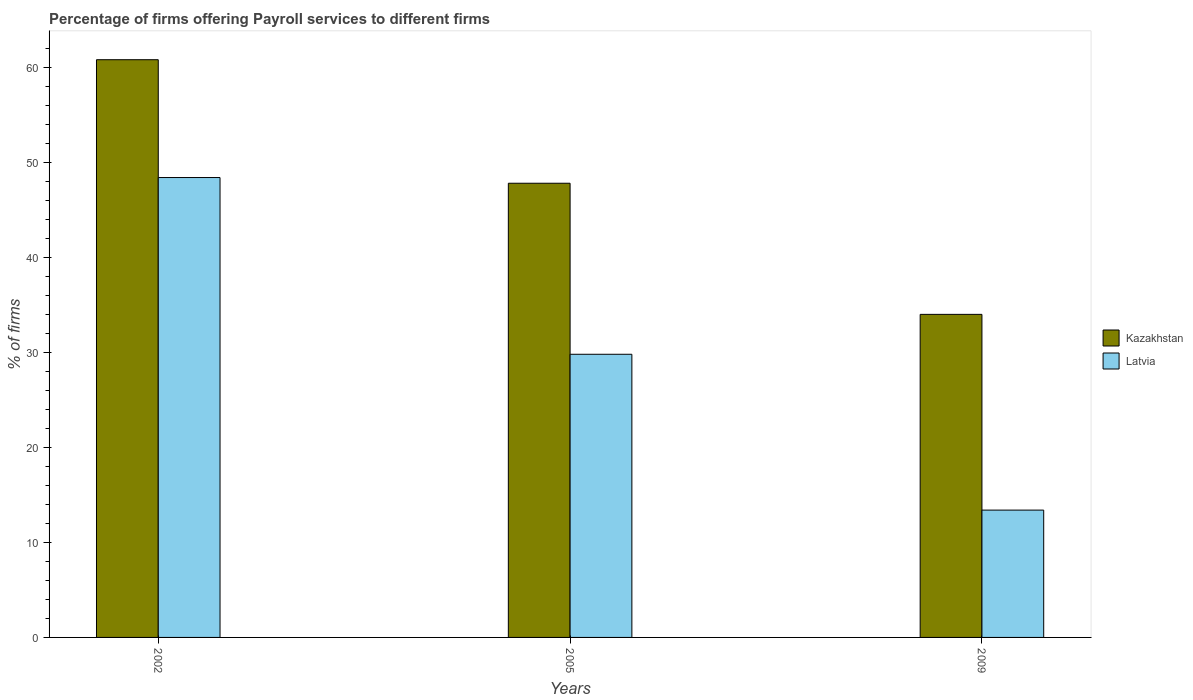Are the number of bars per tick equal to the number of legend labels?
Give a very brief answer. Yes. Are the number of bars on each tick of the X-axis equal?
Your answer should be very brief. Yes. How many bars are there on the 2nd tick from the right?
Provide a short and direct response. 2. What is the label of the 2nd group of bars from the left?
Provide a succinct answer. 2005. What is the percentage of firms offering payroll services in Kazakhstan in 2002?
Make the answer very short. 60.8. Across all years, what is the maximum percentage of firms offering payroll services in Kazakhstan?
Make the answer very short. 60.8. In which year was the percentage of firms offering payroll services in Latvia maximum?
Offer a very short reply. 2002. What is the total percentage of firms offering payroll services in Latvia in the graph?
Keep it short and to the point. 91.6. What is the difference between the percentage of firms offering payroll services in Latvia in 2002 and that in 2005?
Provide a succinct answer. 18.6. What is the difference between the percentage of firms offering payroll services in Kazakhstan in 2005 and the percentage of firms offering payroll services in Latvia in 2009?
Your response must be concise. 34.4. What is the average percentage of firms offering payroll services in Latvia per year?
Your response must be concise. 30.53. In the year 2005, what is the difference between the percentage of firms offering payroll services in Kazakhstan and percentage of firms offering payroll services in Latvia?
Offer a very short reply. 18. In how many years, is the percentage of firms offering payroll services in Kazakhstan greater than 60 %?
Offer a very short reply. 1. What is the ratio of the percentage of firms offering payroll services in Latvia in 2002 to that in 2009?
Offer a terse response. 3.61. Is the percentage of firms offering payroll services in Kazakhstan in 2002 less than that in 2005?
Your response must be concise. No. What is the difference between the highest and the second highest percentage of firms offering payroll services in Latvia?
Ensure brevity in your answer.  18.6. What is the difference between the highest and the lowest percentage of firms offering payroll services in Kazakhstan?
Offer a terse response. 26.8. What does the 1st bar from the left in 2002 represents?
Your answer should be very brief. Kazakhstan. What does the 1st bar from the right in 2005 represents?
Provide a short and direct response. Latvia. Are all the bars in the graph horizontal?
Your response must be concise. No. How many years are there in the graph?
Your answer should be compact. 3. Are the values on the major ticks of Y-axis written in scientific E-notation?
Give a very brief answer. No. Does the graph contain any zero values?
Offer a terse response. No. Does the graph contain grids?
Make the answer very short. No. Where does the legend appear in the graph?
Your answer should be compact. Center right. How are the legend labels stacked?
Keep it short and to the point. Vertical. What is the title of the graph?
Your response must be concise. Percentage of firms offering Payroll services to different firms. What is the label or title of the Y-axis?
Keep it short and to the point. % of firms. What is the % of firms of Kazakhstan in 2002?
Ensure brevity in your answer.  60.8. What is the % of firms of Latvia in 2002?
Give a very brief answer. 48.4. What is the % of firms in Kazakhstan in 2005?
Offer a terse response. 47.8. What is the % of firms in Latvia in 2005?
Offer a terse response. 29.8. What is the % of firms in Latvia in 2009?
Make the answer very short. 13.4. Across all years, what is the maximum % of firms of Kazakhstan?
Provide a succinct answer. 60.8. Across all years, what is the maximum % of firms of Latvia?
Offer a very short reply. 48.4. Across all years, what is the minimum % of firms of Kazakhstan?
Your response must be concise. 34. Across all years, what is the minimum % of firms of Latvia?
Keep it short and to the point. 13.4. What is the total % of firms in Kazakhstan in the graph?
Provide a short and direct response. 142.6. What is the total % of firms of Latvia in the graph?
Your answer should be very brief. 91.6. What is the difference between the % of firms of Kazakhstan in 2002 and that in 2005?
Offer a very short reply. 13. What is the difference between the % of firms in Latvia in 2002 and that in 2005?
Offer a very short reply. 18.6. What is the difference between the % of firms of Kazakhstan in 2002 and that in 2009?
Offer a terse response. 26.8. What is the difference between the % of firms of Latvia in 2002 and that in 2009?
Your answer should be very brief. 35. What is the difference between the % of firms in Kazakhstan in 2005 and that in 2009?
Your answer should be compact. 13.8. What is the difference between the % of firms in Latvia in 2005 and that in 2009?
Offer a terse response. 16.4. What is the difference between the % of firms of Kazakhstan in 2002 and the % of firms of Latvia in 2009?
Keep it short and to the point. 47.4. What is the difference between the % of firms in Kazakhstan in 2005 and the % of firms in Latvia in 2009?
Provide a short and direct response. 34.4. What is the average % of firms in Kazakhstan per year?
Offer a very short reply. 47.53. What is the average % of firms in Latvia per year?
Provide a short and direct response. 30.53. In the year 2002, what is the difference between the % of firms in Kazakhstan and % of firms in Latvia?
Your answer should be compact. 12.4. In the year 2009, what is the difference between the % of firms in Kazakhstan and % of firms in Latvia?
Make the answer very short. 20.6. What is the ratio of the % of firms of Kazakhstan in 2002 to that in 2005?
Your response must be concise. 1.27. What is the ratio of the % of firms in Latvia in 2002 to that in 2005?
Offer a very short reply. 1.62. What is the ratio of the % of firms in Kazakhstan in 2002 to that in 2009?
Provide a short and direct response. 1.79. What is the ratio of the % of firms in Latvia in 2002 to that in 2009?
Ensure brevity in your answer.  3.61. What is the ratio of the % of firms of Kazakhstan in 2005 to that in 2009?
Keep it short and to the point. 1.41. What is the ratio of the % of firms in Latvia in 2005 to that in 2009?
Provide a short and direct response. 2.22. What is the difference between the highest and the lowest % of firms in Kazakhstan?
Provide a succinct answer. 26.8. 